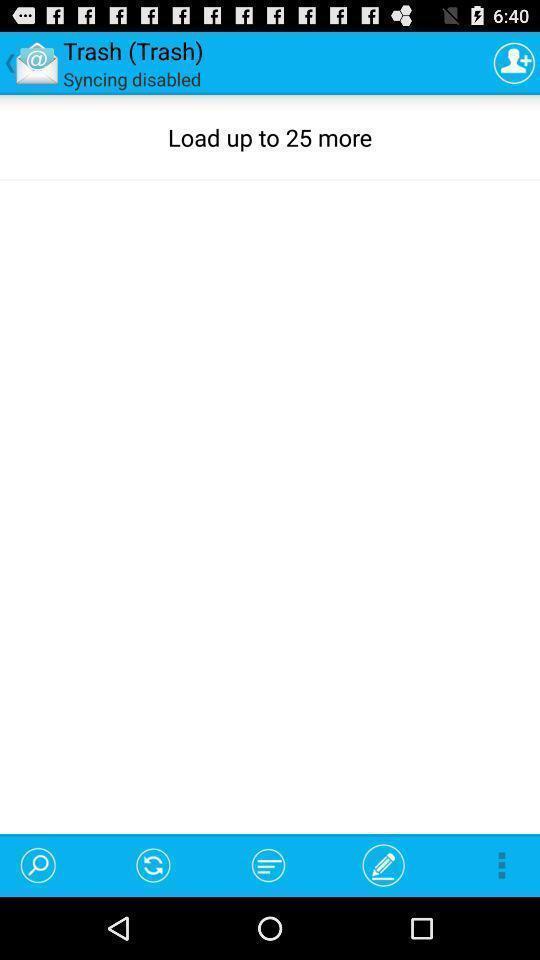Explain the elements present in this screenshot. Page showing trash in a social app. 